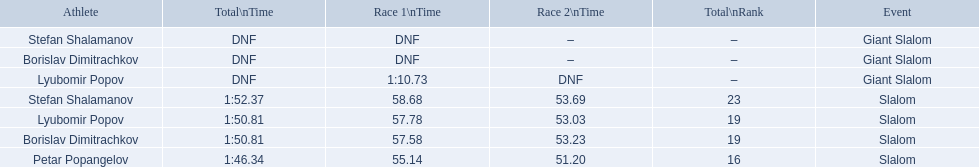Which event is the giant slalom? Giant Slalom, Giant Slalom, Giant Slalom. Which one is lyubomir popov? Lyubomir Popov. What is race 1 tim? 1:10.73. 